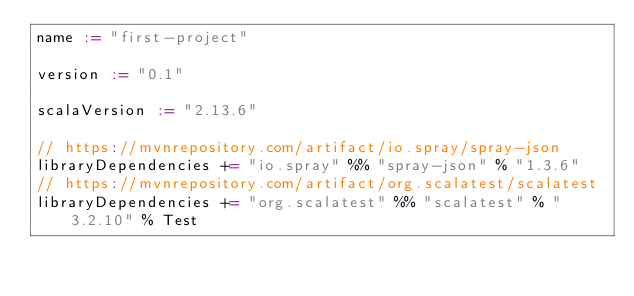Convert code to text. <code><loc_0><loc_0><loc_500><loc_500><_Scala_>name := "first-project"

version := "0.1"

scalaVersion := "2.13.6"

// https://mvnrepository.com/artifact/io.spray/spray-json
libraryDependencies += "io.spray" %% "spray-json" % "1.3.6"
// https://mvnrepository.com/artifact/org.scalatest/scalatest
libraryDependencies += "org.scalatest" %% "scalatest" % "3.2.10" % Test

</code> 